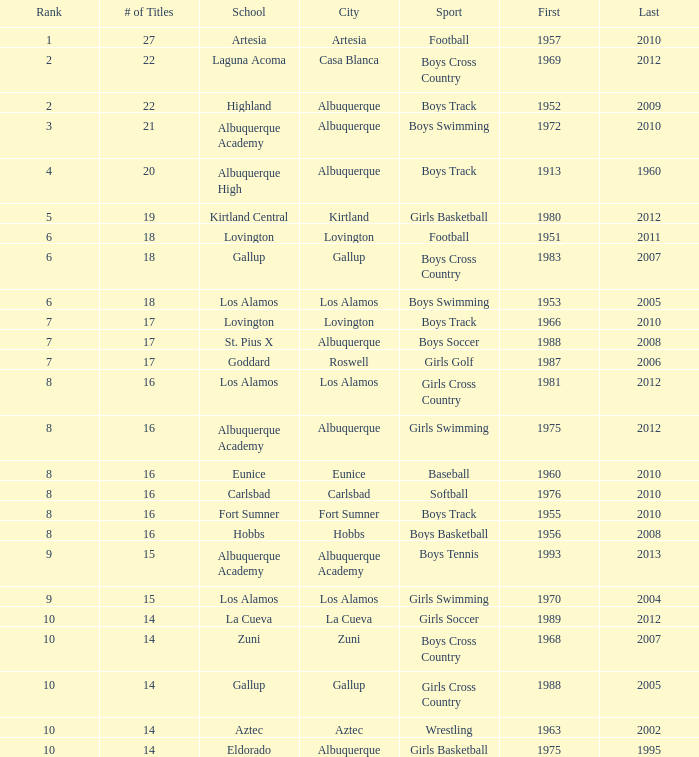What city is the School, Highland, in that ranks less than 8 and had its first title before 1980 and its last title later than 1960? Albuquerque. 